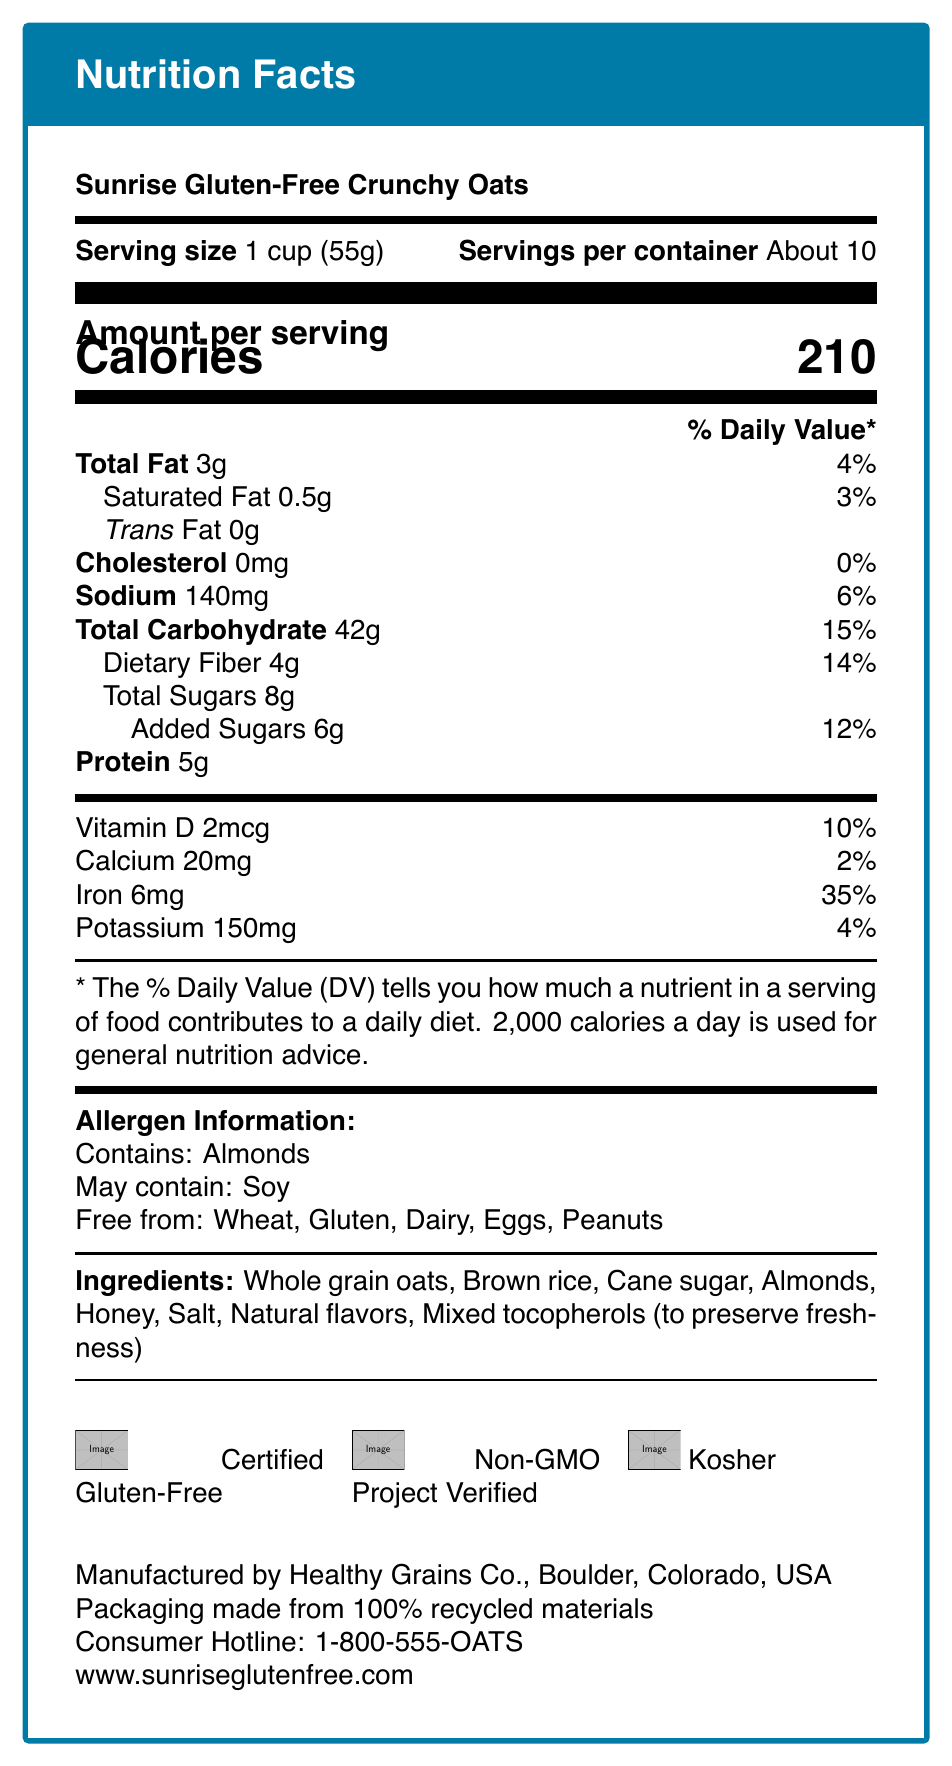who is the manufacturer of Sunrise Gluten-Free Crunchy Oats? The manufacturer information is provided in the document under the nutrition facts and cereal details.
Answer: Healthy Grains Co. what is the serving size for the cereal? The serving size is mentioned at the top of the Nutrition Facts section.
Answer: 1 cup (55g) how many calories are in one serving? The number of calories per serving is prominently displayed in the "Amount per serving" section.
Answer: 210 calories what is the total fat content per serving? The total fat content is listed under the "Total Fat" section.
Answer: 3g what allergens does the cereal contain? The allergen information shows that the cereal contains almonds.
Answer: Almonds how much iron does a serving provide? The amount of iron per serving is listed in the vitamin and mineral content section.
Answer: 6mg what percentage of the daily value for dietary fiber is in one serving? The percentage of daily value for dietary fiber is provided next to the fiber content.
Answer: 14% is this cereal free from gluten? The cereal is certified gluten-free and the allergen information mentions it is free from gluten.
Answer: Yes which certifications does the cereal have? A. Organic B. Non-GMO Project Verified C. Fair Trade D. Heart-Healthy The certifications section shows that the cereal is Non-GMO Project Verified among other certifications.
Answer: B how much added sugar does the cereal contain? A. 4g B. 6g C. 8g D. 2g The added sugars are specifically mentioned as 6 grams in the nutrition facts.
Answer: B is the cereal manufactured in Boulder, California? The document states that the cereal is manufactured in Boulder, Colorado, not California.
Answer: No summarize the key information provided in the document. The document gives detailed information about the cereal's nutritional content, allergen warnings, ingredients, certifications, manufacturing location, and contact information.
Answer: This document provides the nutrition facts, allergen information, ingredient list, certifications, manufacturer details, and sustainability note for Sunrise Gluten-Free Crunchy Oats. It highlights that the cereal is gluten-free and contains almonds but may contain soy. Key nutrients are prominently displayed along with their daily values based on a 2,000 calorie diet. how much calcium is in one serving of the cereal? The calcium content is listed in the vitamin and mineral content section at the bottom of the nutrition facts.
Answer: 20mg what is the total carbohydrate content per serving? The total carbohydrate content is listed under the "Total Carbohydrate" section.
Answer: 42g what is the consumer hotline number? The consumer hotline number is provided at the bottom of the document.
Answer: 1-800-555-OATS are the packaging materials used for the cereal recyclable? The sustainability note mentions that the packaging is made from 100% recycled materials.
Answer: Yes is there information about the product's organic certification in the document? The document lists several certifications, but organic certification is not one of them.
Answer: No, there is no information about organic certification in the document. 